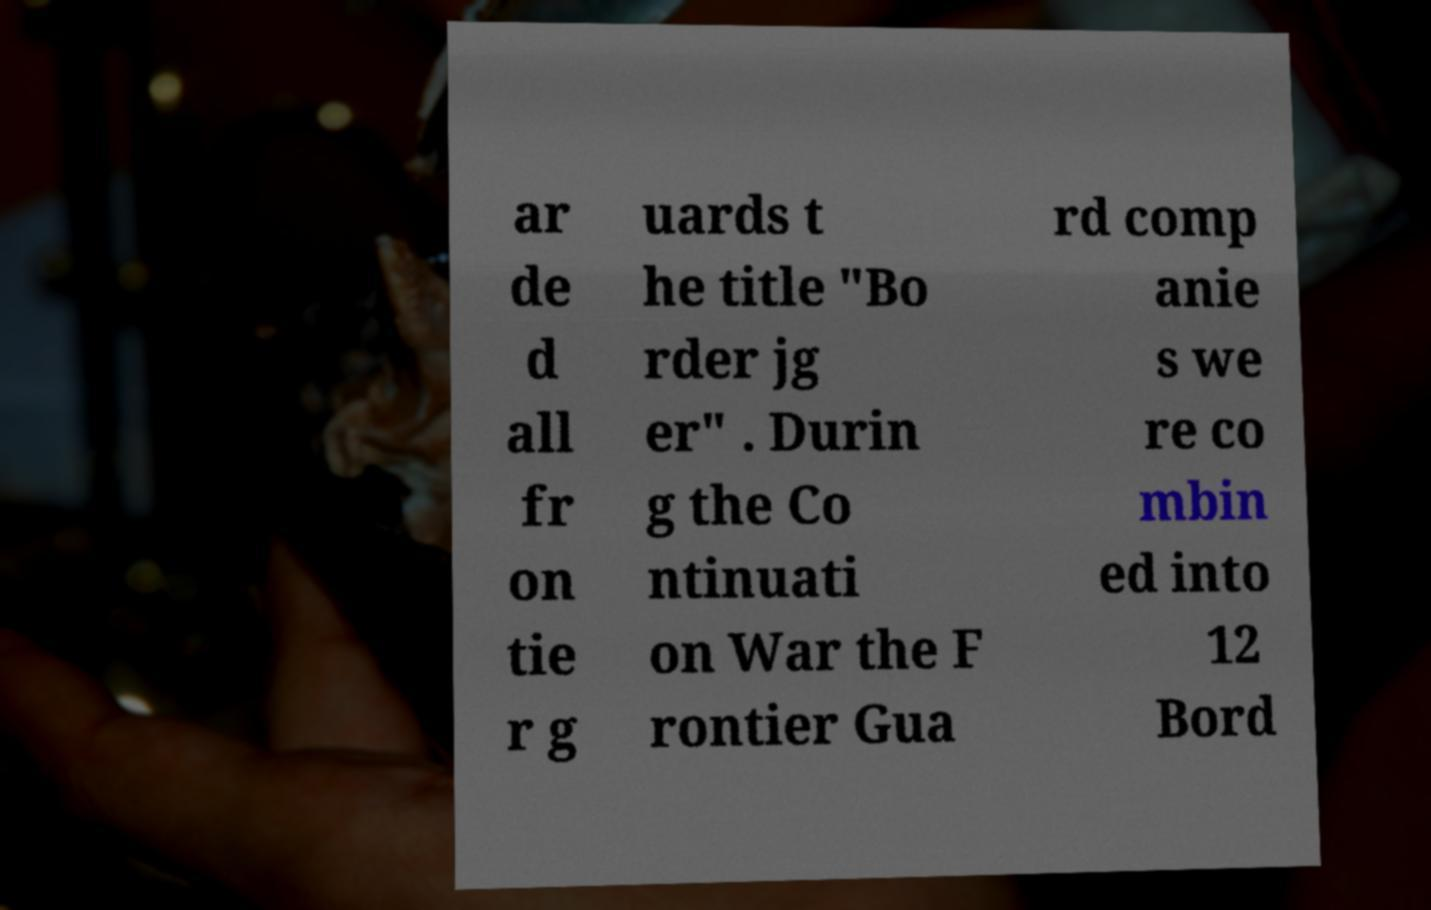Can you accurately transcribe the text from the provided image for me? ar de d all fr on tie r g uards t he title "Bo rder jg er" . Durin g the Co ntinuati on War the F rontier Gua rd comp anie s we re co mbin ed into 12 Bord 